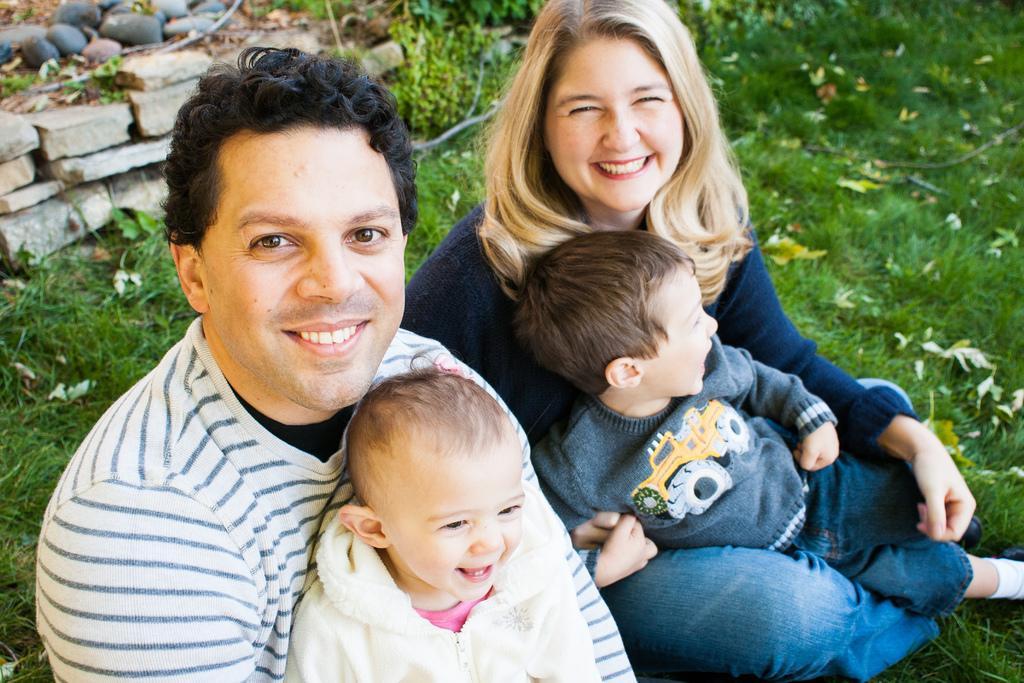Could you give a brief overview of what you see in this image? In this picture I can see two kids sitting on the man and a woman. I can see grass, leaves and stones. 